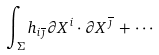<formula> <loc_0><loc_0><loc_500><loc_500>\int _ { \Sigma } h _ { i \overline { \jmath } } \partial X ^ { i } \cdot \partial X ^ { \overline { \jmath } } \, + \, \cdots</formula> 